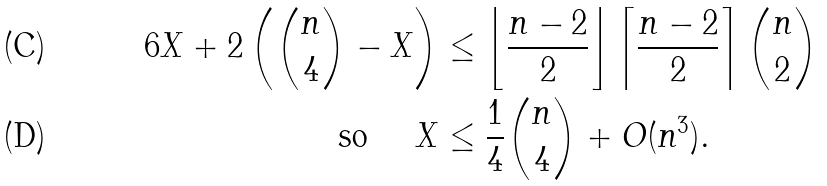Convert formula to latex. <formula><loc_0><loc_0><loc_500><loc_500>6 X + 2 \left ( \binom { n } { 4 } - X \right ) & \leq \left \lfloor \frac { n - 2 } { 2 } \right \rfloor \left \lceil \frac { n - 2 } { 2 } \right \rceil \binom { n } { 2 } \\ \text {so } \quad X & \leq \frac { 1 } { 4 } \binom { n } { 4 } + O ( n ^ { 3 } ) .</formula> 